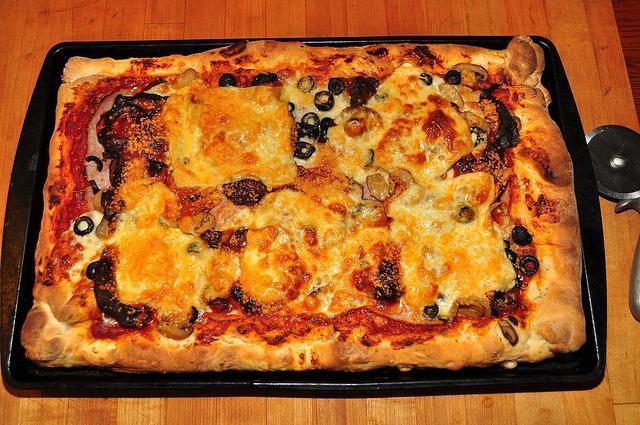How many people are behind the train?
Give a very brief answer. 0. 